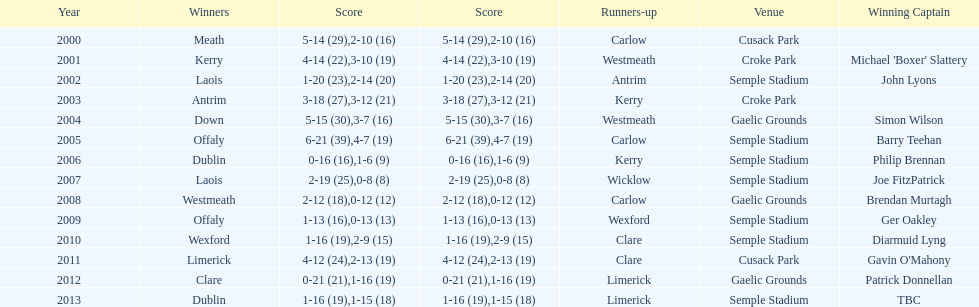Who emerged victorious following 2007? Laois. 